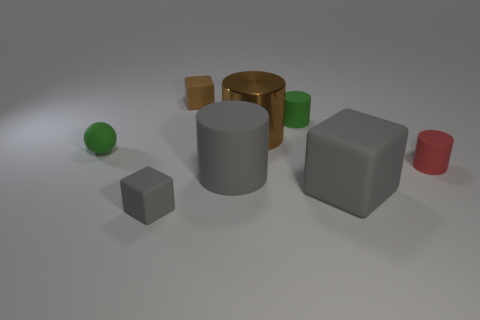Are there any other things of the same color as the big block?
Ensure brevity in your answer.  Yes. There is another small matte thing that is the same shape as the red rubber object; what is its color?
Offer a very short reply. Green. Are there more things in front of the sphere than rubber cubes?
Offer a very short reply. Yes. What is the color of the matte block that is left of the small brown thing?
Ensure brevity in your answer.  Gray. Do the metal thing and the gray cylinder have the same size?
Give a very brief answer. Yes. The metal cylinder is what size?
Give a very brief answer. Large. What shape is the rubber thing that is the same color as the metal object?
Your answer should be very brief. Cube. Are there more small gray things than green objects?
Your answer should be very brief. No. What is the color of the rubber object in front of the big object that is to the right of the rubber cylinder that is behind the metal cylinder?
Offer a very short reply. Gray. There is a small thing that is in front of the small red cylinder; is it the same shape as the small brown thing?
Keep it short and to the point. Yes. 